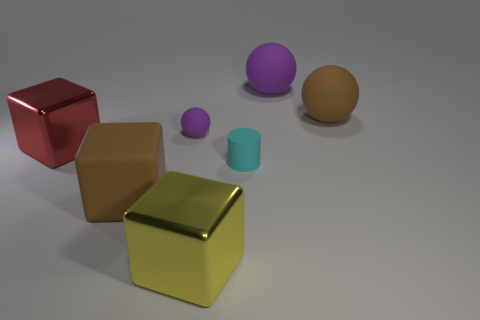How do the shapes in the image differ in terms of their geometry? In the image, we can observe a variety of geometric shapes. There is a cube, which has six equal square faces, edges of equal length, and every angle is a right angle. The sphere possesses a single continuous curved surface with every point on its surface equidistant from its center. The cylinder has two parallel circular bases connected by a curved surface at a fixed distance from each other. Additionally, there's what appears to be a rectangular prism with six faces at various angles. The variety of shapes makes for an interesting study in geometry. 